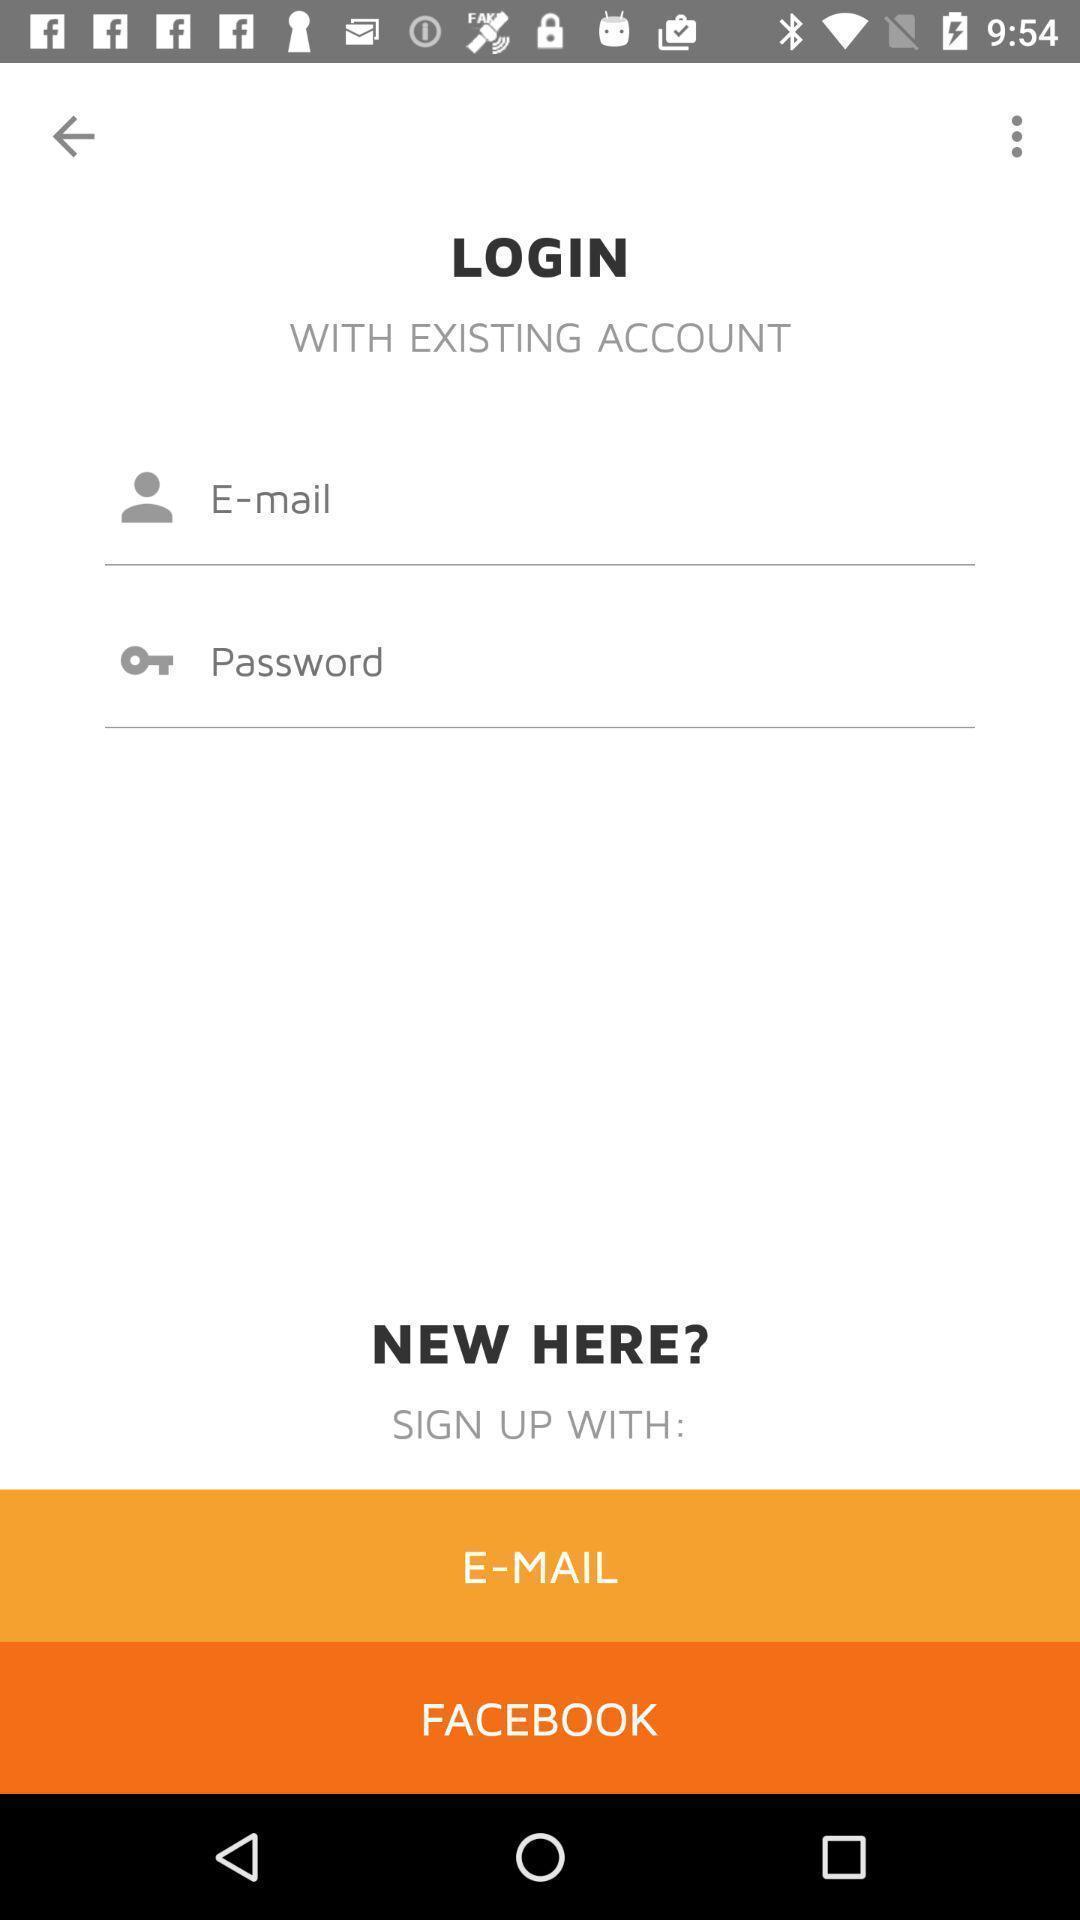Describe the content in this image. Sign in page by using social application. 